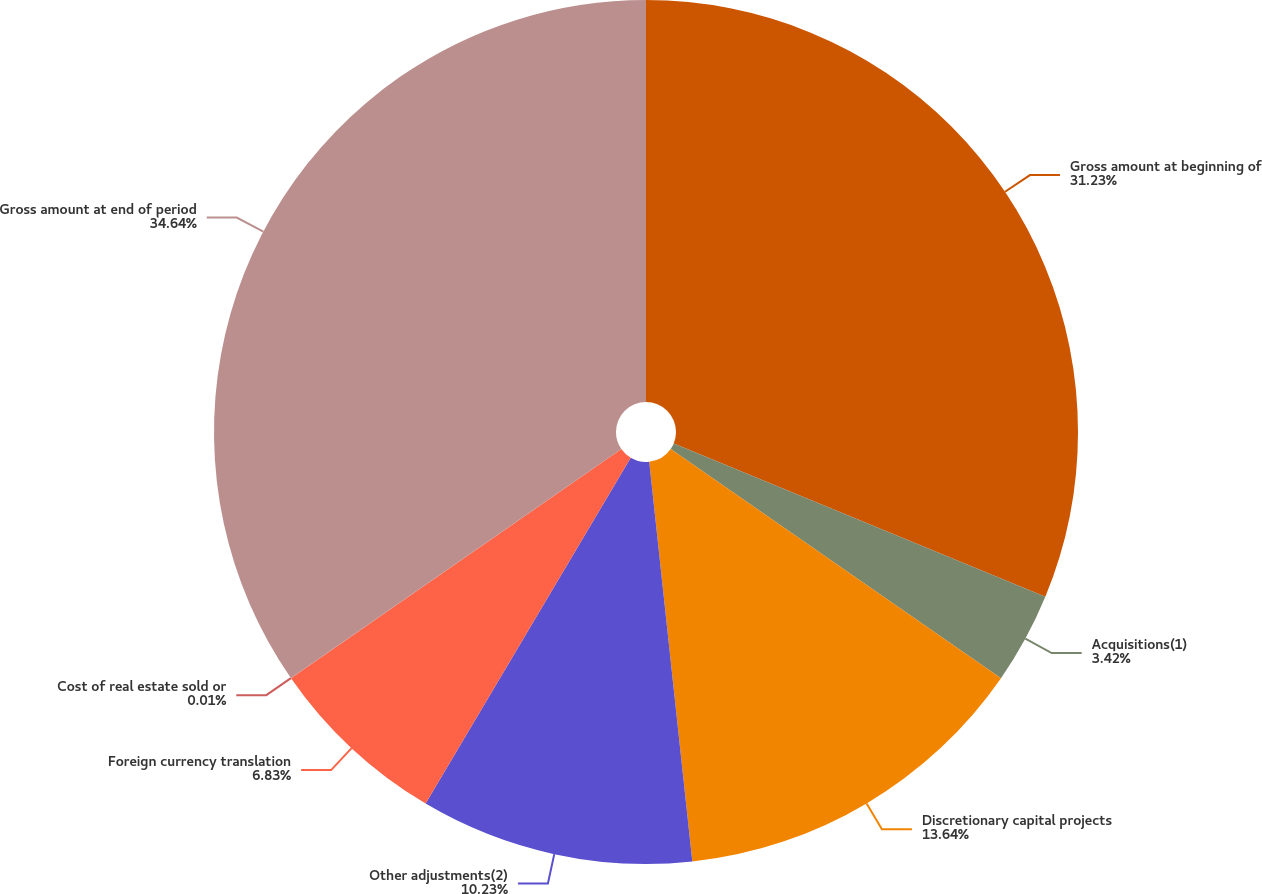Convert chart. <chart><loc_0><loc_0><loc_500><loc_500><pie_chart><fcel>Gross amount at beginning of<fcel>Acquisitions(1)<fcel>Discretionary capital projects<fcel>Other adjustments(2)<fcel>Foreign currency translation<fcel>Cost of real estate sold or<fcel>Gross amount at end of period<nl><fcel>31.23%<fcel>3.42%<fcel>13.64%<fcel>10.23%<fcel>6.83%<fcel>0.01%<fcel>34.64%<nl></chart> 